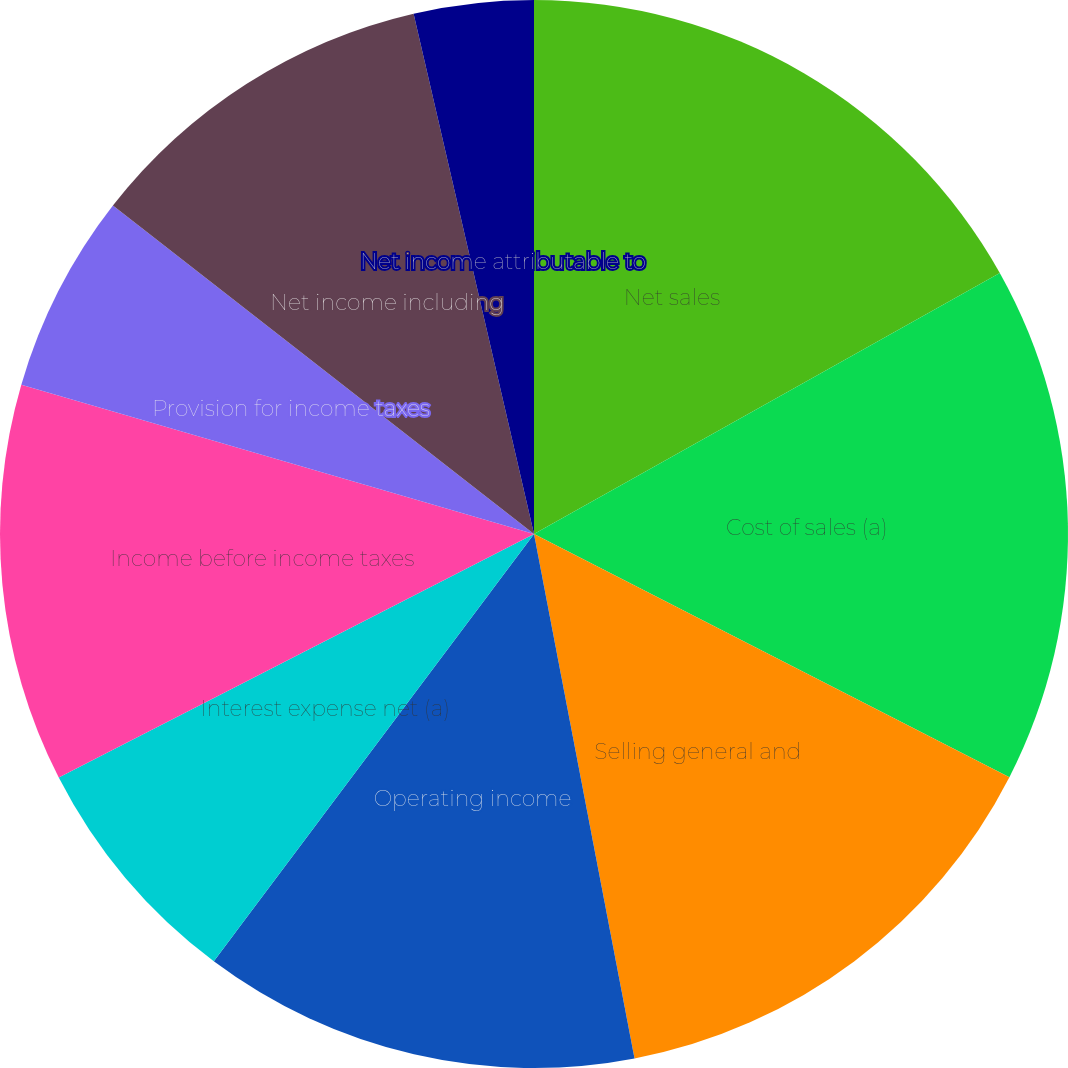Convert chart to OTSL. <chart><loc_0><loc_0><loc_500><loc_500><pie_chart><fcel>Net sales<fcel>Cost of sales (a)<fcel>Selling general and<fcel>Special (gains) and charges<fcel>Operating income<fcel>Interest expense net (a)<fcel>Income before income taxes<fcel>Provision for income taxes<fcel>Net income including<fcel>Net income attributable to<nl><fcel>16.87%<fcel>15.66%<fcel>14.46%<fcel>0.0%<fcel>13.25%<fcel>7.23%<fcel>12.05%<fcel>6.03%<fcel>10.84%<fcel>3.62%<nl></chart> 